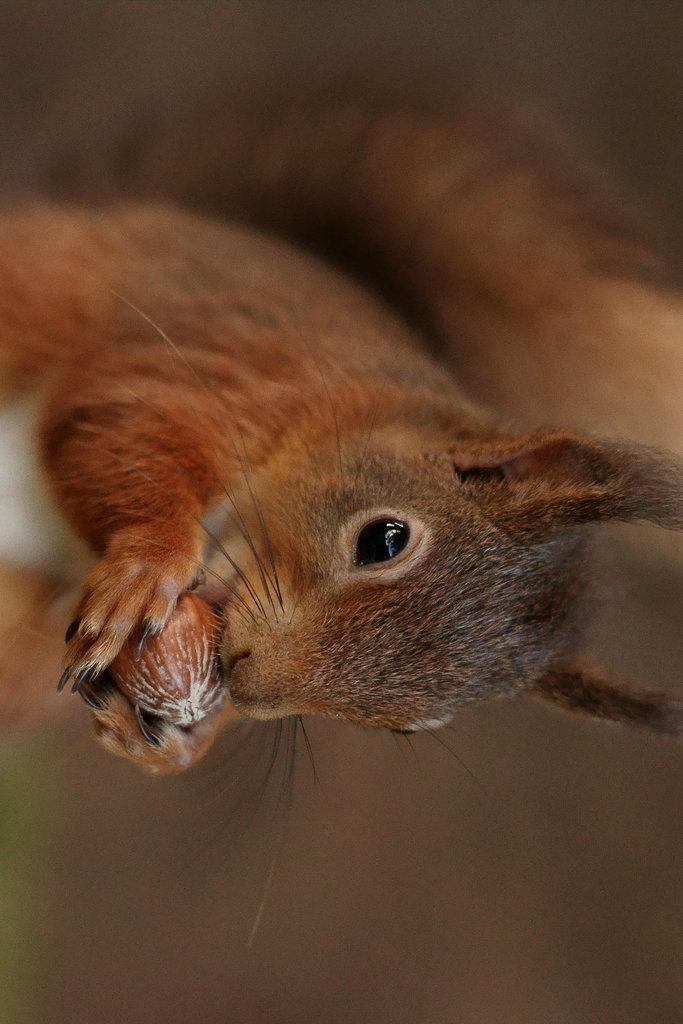In one or two sentences, can you explain what this image depicts? Background portion of the picture is blur. In this picture we can see a squirrel having food. 